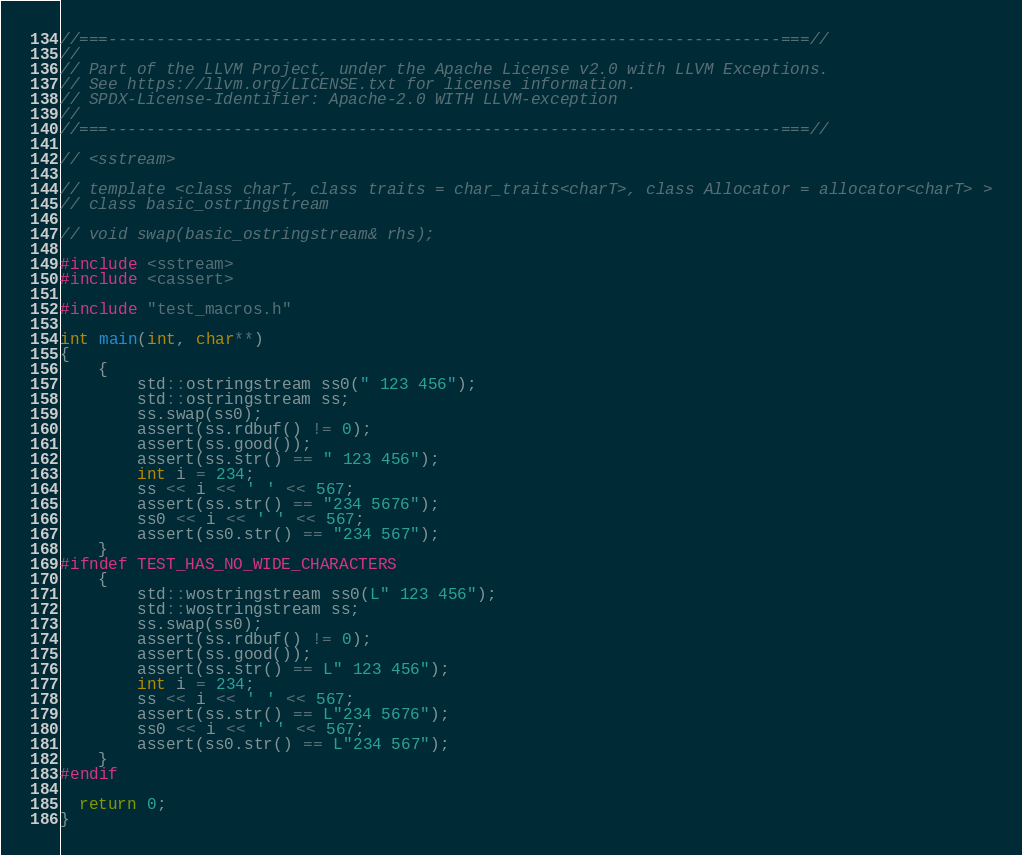Convert code to text. <code><loc_0><loc_0><loc_500><loc_500><_C++_>//===----------------------------------------------------------------------===//
//
// Part of the LLVM Project, under the Apache License v2.0 with LLVM Exceptions.
// See https://llvm.org/LICENSE.txt for license information.
// SPDX-License-Identifier: Apache-2.0 WITH LLVM-exception
//
//===----------------------------------------------------------------------===//

// <sstream>

// template <class charT, class traits = char_traits<charT>, class Allocator = allocator<charT> >
// class basic_ostringstream

// void swap(basic_ostringstream& rhs);

#include <sstream>
#include <cassert>

#include "test_macros.h"

int main(int, char**)
{
    {
        std::ostringstream ss0(" 123 456");
        std::ostringstream ss;
        ss.swap(ss0);
        assert(ss.rdbuf() != 0);
        assert(ss.good());
        assert(ss.str() == " 123 456");
        int i = 234;
        ss << i << ' ' << 567;
        assert(ss.str() == "234 5676");
        ss0 << i << ' ' << 567;
        assert(ss0.str() == "234 567");
    }
#ifndef TEST_HAS_NO_WIDE_CHARACTERS
    {
        std::wostringstream ss0(L" 123 456");
        std::wostringstream ss;
        ss.swap(ss0);
        assert(ss.rdbuf() != 0);
        assert(ss.good());
        assert(ss.str() == L" 123 456");
        int i = 234;
        ss << i << ' ' << 567;
        assert(ss.str() == L"234 5676");
        ss0 << i << ' ' << 567;
        assert(ss0.str() == L"234 567");
    }
#endif

  return 0;
}
</code> 